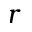<formula> <loc_0><loc_0><loc_500><loc_500>r</formula> 